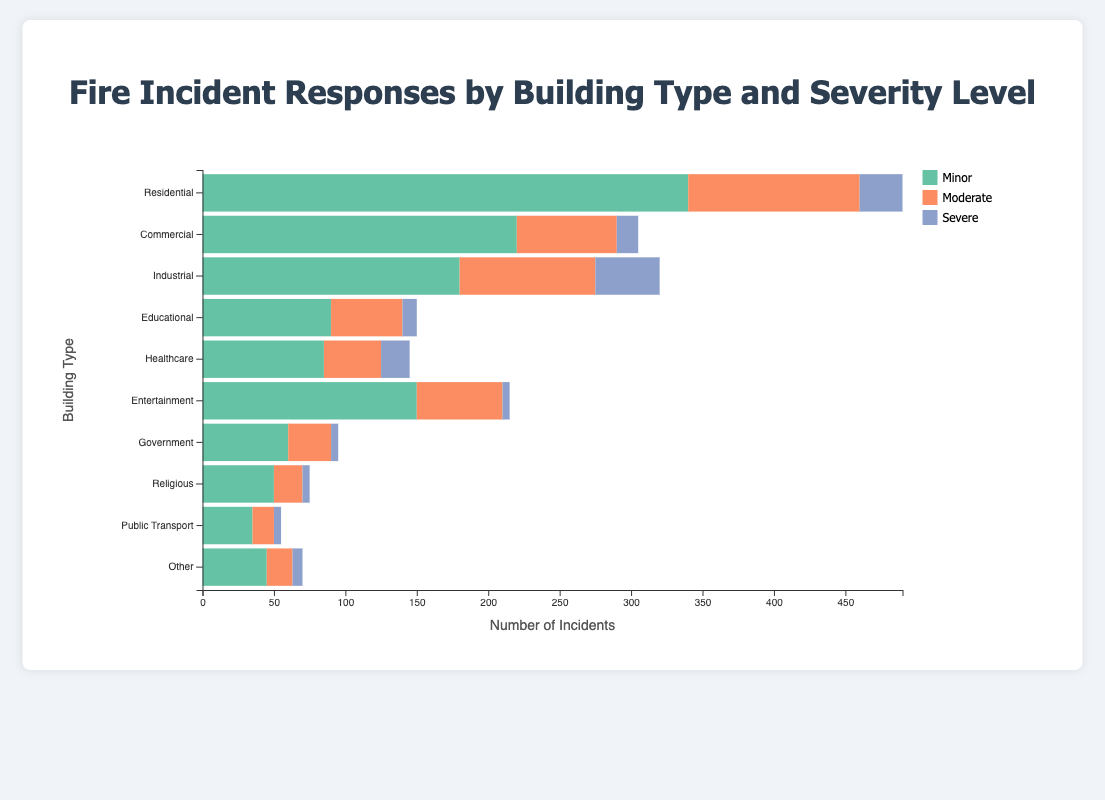What type of building has the highest number of total fire incident responses? The residential building type has the highest total fire incident responses. Summing up the values for Residential: 340 (Minor) + 120 (Moderate) + 30 (Severe) = 490. No other building type surpasses this total.
Answer: Residential Which severity level is most common for Industrial buildings? For Industrial buildings, the highest number of incidents is in the Minor severity level. The values are 180 (Minor), 95 (Moderate), and 45 (Severe).
Answer: Minor How do the numbers of Minor and Severe responses compare for Healthcare buildings? For Healthcare buildings, there are 85 Minor responses and 20 Severe responses. Comparing these, there are significantly more Minor responses than Severe responses.
Answer: More Minor responses What's the combined number of Moderate and Severe responses for Entertainment buildings? For Entertainment buildings, the number of Moderate responses is 60 and Severe responses is 5. Adding these together gives 60 + 5 = 65.
Answer: 65 Which building type has the lowest number of total fire incident responses? Summing up the total responses for each building type, Public Transport has the lowest total: 35 (Minor) + 15 (Moderate) + 5 (Severe) = 55.
Answer: Public Transport Are there more Minor responses for Commercial or Industrial buildings? Comparing Minor responses: Commercial has 220 and Industrial has 180. Therefore, Commercial buildings have more Minor responses.
Answer: Commercial In terms of Severe fire incidents, which building type ranks the second highest? Reviewing the values, the second highest number of Severe responses is in Industrial buildings with 45. Residential is first with 30.
Answer: Industrial What's the difference between the total number of Moderate incidents in Government and Educational buildings? The total Moderate incidents for Government buildings are 30, and for Educational buildings are 50. The difference is 50 - 30 = 20.
Answer: 20 What percentage of the total incidents in Religious buildings are of Minor severity? For Religious buildings, there are 75 total incidents: 50 (Minor) + 20 (Moderate) + 5 (Severe). To find the percentage of Minor incidents: (50 / 75) * 100 = approximately 66.67%.
Answer: Approximately 66.67% If we combine the number of Moderate incidents from Commercial and Residential buildings, how many more incidents do we get compared to the combined Moderate incidents from Government and Entertainment buildings? Summing Moderate incidents: Commercial (70) + Residential (120) = 190; Government (30) + Entertainment (60) = 90. The difference is 190 - 90 = 100.
Answer: 100 